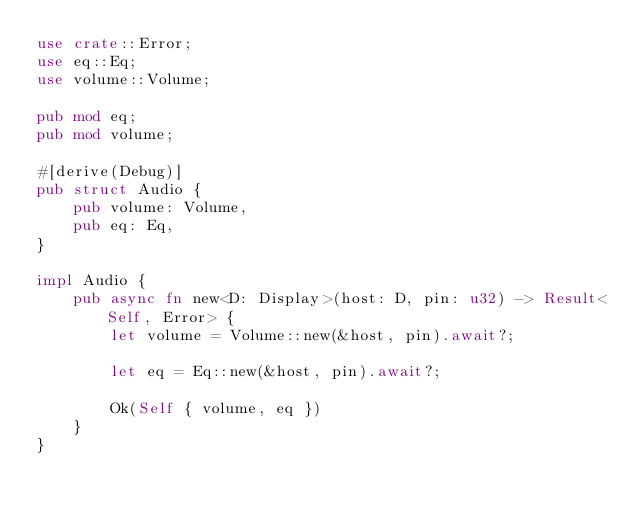<code> <loc_0><loc_0><loc_500><loc_500><_Rust_>use crate::Error;
use eq::Eq;
use volume::Volume;

pub mod eq;
pub mod volume;

#[derive(Debug)]
pub struct Audio {
    pub volume: Volume,
    pub eq: Eq,
}

impl Audio {
    pub async fn new<D: Display>(host: D, pin: u32) -> Result<Self, Error> {
        let volume = Volume::new(&host, pin).await?;

        let eq = Eq::new(&host, pin).await?;

        Ok(Self { volume, eq })
    }
}
</code> 